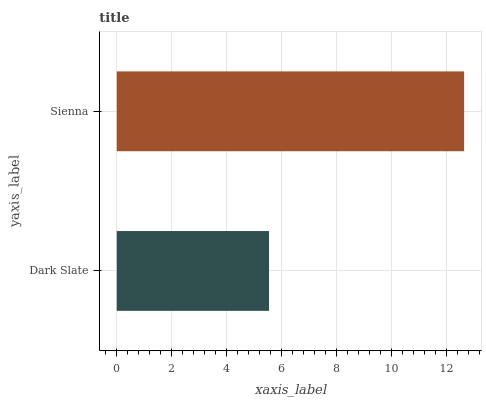Is Dark Slate the minimum?
Answer yes or no. Yes. Is Sienna the maximum?
Answer yes or no. Yes. Is Sienna the minimum?
Answer yes or no. No. Is Sienna greater than Dark Slate?
Answer yes or no. Yes. Is Dark Slate less than Sienna?
Answer yes or no. Yes. Is Dark Slate greater than Sienna?
Answer yes or no. No. Is Sienna less than Dark Slate?
Answer yes or no. No. Is Sienna the high median?
Answer yes or no. Yes. Is Dark Slate the low median?
Answer yes or no. Yes. Is Dark Slate the high median?
Answer yes or no. No. Is Sienna the low median?
Answer yes or no. No. 